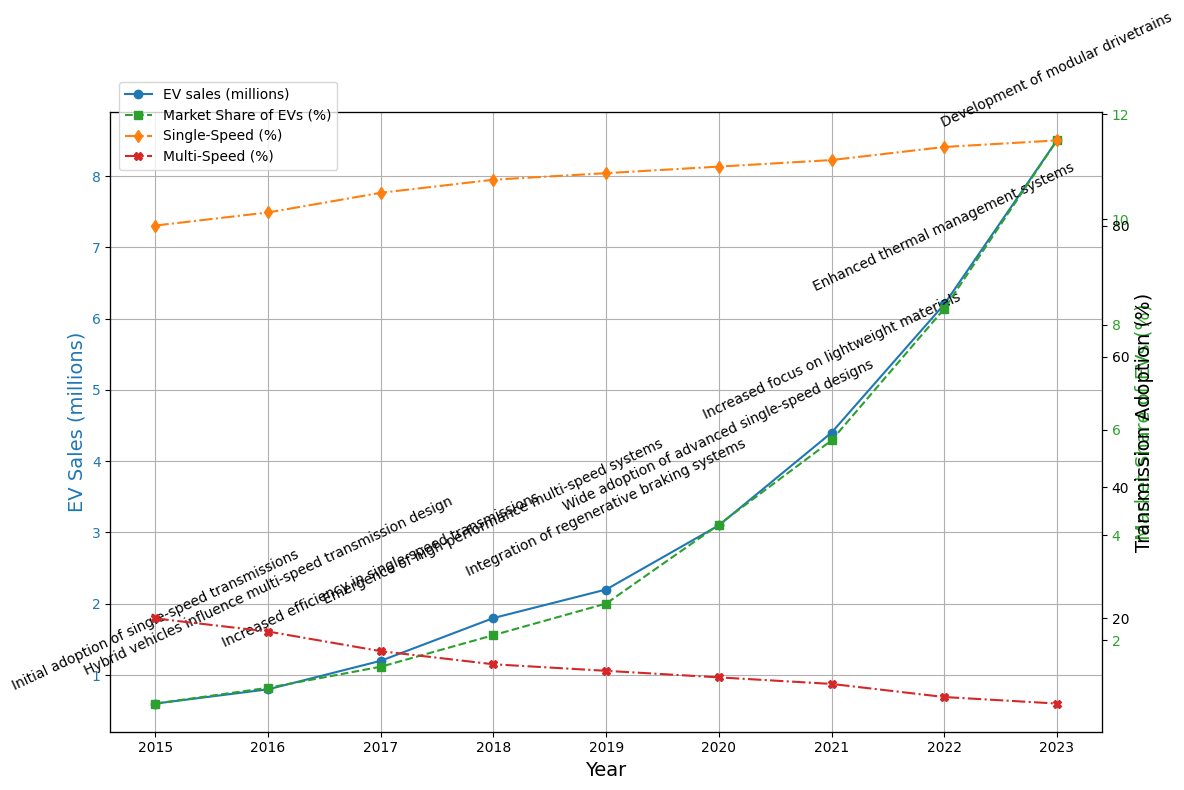What's the trend in Electric Vehicle (EV) sales from 2015 to 2023? The plot shows a continuous increase in EV sales over the years, starting from 0.6 million in 2015 and reaching 8.5 million in 2023. This indicates a steady and significant upward trend.
Answer: Continuous increase How does the market share of EVs change from 2015 to 2023? The market share of EVs in the plot also increases steadily from 0.8% in 2015 to 11.5% in 2023, suggesting that EVs are becoming a more dominant part of the vehicle market over time.
Answer: Steady increase What is the difference in the adoption percentage between single-speed and multi-speed transmissions in 2023? In 2023, the adoption of single-speed transmissions is 93%, and for multi-speed transmissions, it is 7%. The difference is 93% - 7% = 86%.
Answer: 86% Which year shows the highest market share for EVs and what is its percentage? The year 2023 shows the highest market share for EVs, with a percentage of 11.5%.
Answer: 2023, 11.5% Compare the trends of single-speed and multi-speed transmission adoption from 2015 to 2023. The plot shows that the adoption of single-speed transmissions increases steadily from 80% in 2015 to 93% in 2023, whereas the adoption of multi-speed transmissions decreases from 20% in 2015 to 7% in 2023.
Answer: Increase in single-speed, decrease in multi-speed What advancement in drivetrain technology is noted in 2019? The annotation for the year 2019 mentions "Integration of regenerative braking systems" as the advancement in drivetrain technology.
Answer: Integration of regenerative braking systems How did the adoption of multi-speed transmissions change from 2017 to 2018? The adoption of multi-speed transmissions decreased from 15% in 2017 to 13% in 2018, showing a 2% decrease over this period.
Answer: Decrease by 2% What is the average market share of EVs between 2015 and 2023? Sum the market shares for each year (0.8 + 1.1 + 1.5 + 2.1 + 2.7 + 4.2 + 5.8 + 8.3 + 11.5) which equals 37, then divide by the number of years (9), resulting in an average market share of 37/9 ≈ 4.11%.
Answer: 4.11% What color represents EV sales in the plot? The plot uses a blue line with circular markers to represent EV sales.
Answer: Blue Between which years did the electric vehicle sales experience the largest increase? The largest increase in EV sales is observed between 2021 and 2022, where sales increased from 4.4 million to 6.2 million, a difference of 1.8 million.
Answer: 2021-2022 